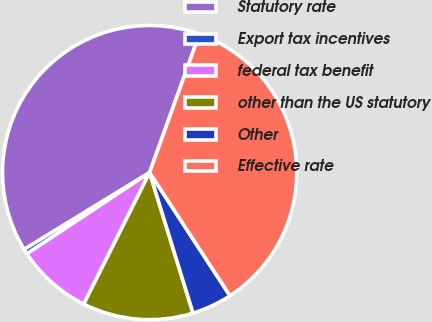Convert chart. <chart><loc_0><loc_0><loc_500><loc_500><pie_chart><fcel>Statutory rate<fcel>Export tax incentives<fcel>federal tax benefit<fcel>other than the US statutory<fcel>Other<fcel>Effective rate<nl><fcel>39.24%<fcel>0.56%<fcel>8.3%<fcel>12.16%<fcel>4.43%<fcel>35.31%<nl></chart> 